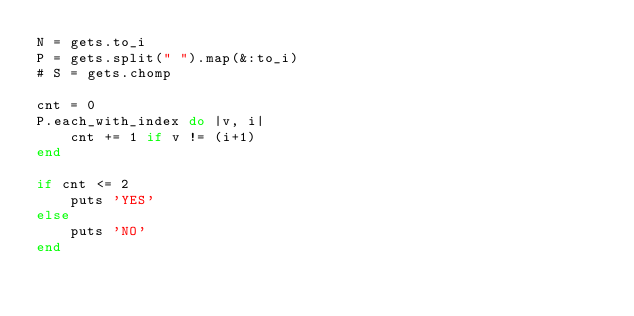Convert code to text. <code><loc_0><loc_0><loc_500><loc_500><_Ruby_>N = gets.to_i
P = gets.split(" ").map(&:to_i)
# S = gets.chomp

cnt = 0
P.each_with_index do |v, i|
    cnt += 1 if v != (i+1)
end

if cnt <= 2
    puts 'YES'
else
    puts 'NO'
end</code> 